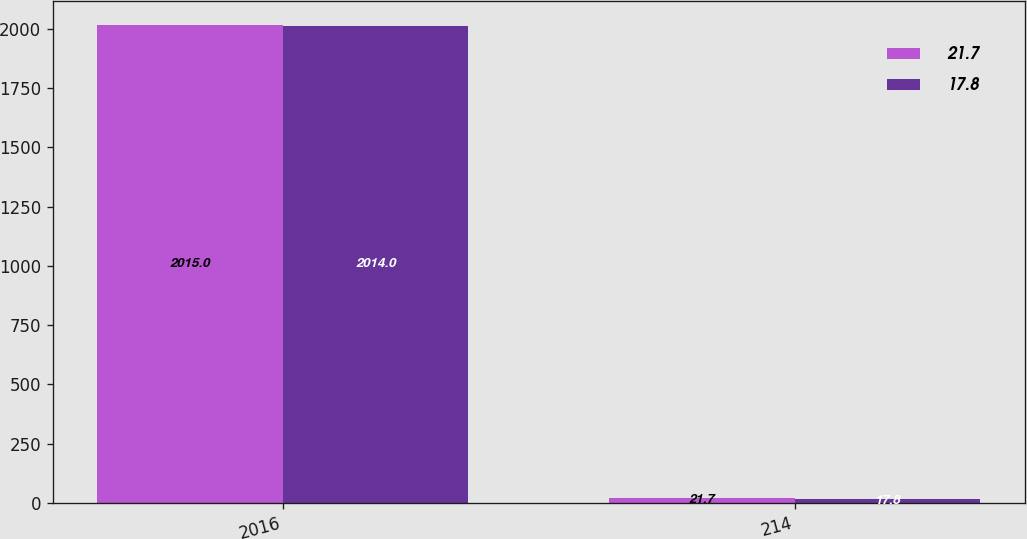Convert chart. <chart><loc_0><loc_0><loc_500><loc_500><stacked_bar_chart><ecel><fcel>2016<fcel>214<nl><fcel>21.7<fcel>2015<fcel>21.7<nl><fcel>17.8<fcel>2014<fcel>17.8<nl></chart> 